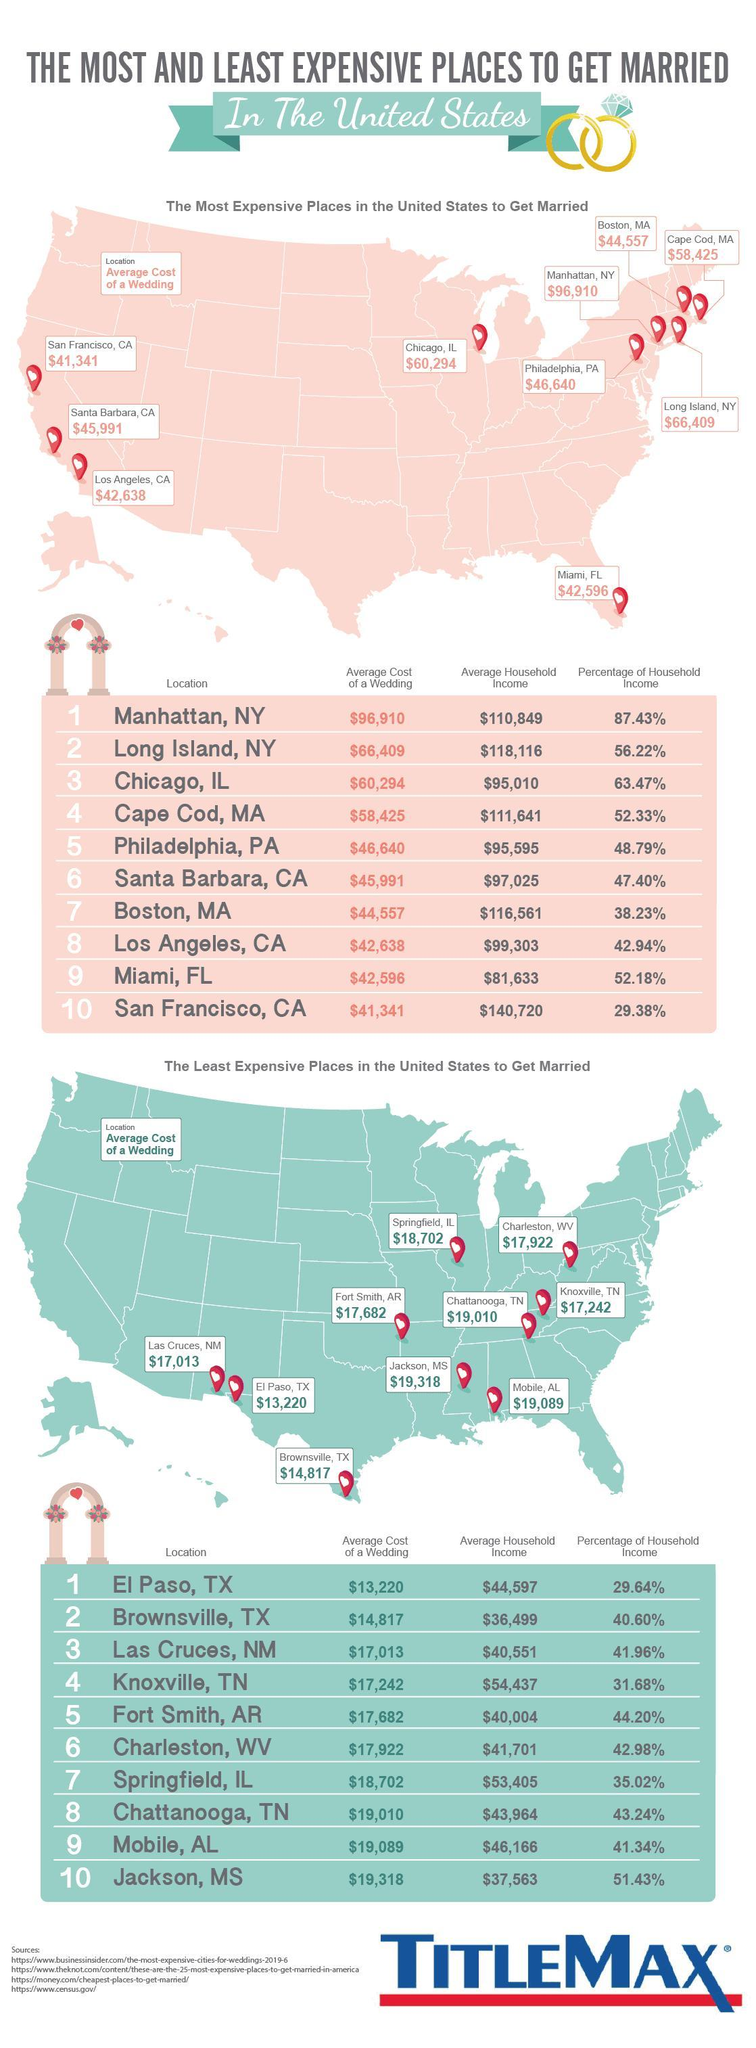Which is the second most expensive place in America to get married?
Answer the question with a short phrase. Long Island, NY Which place in America has the second highest percentage of Household income? Chicago, IL Which is the second least expensive place in America to get married? Brownsville, TX 